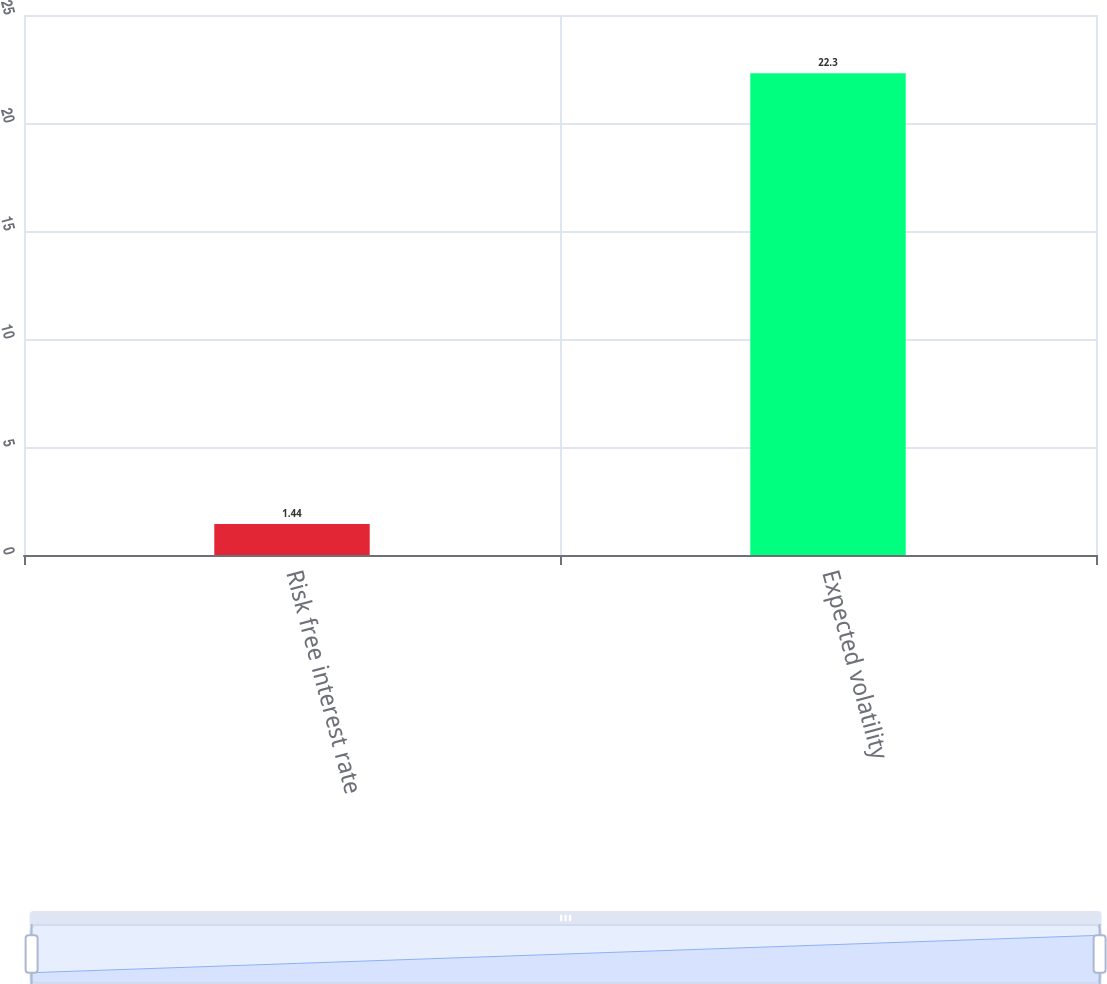Convert chart. <chart><loc_0><loc_0><loc_500><loc_500><bar_chart><fcel>Risk free interest rate<fcel>Expected volatility<nl><fcel>1.44<fcel>22.3<nl></chart> 